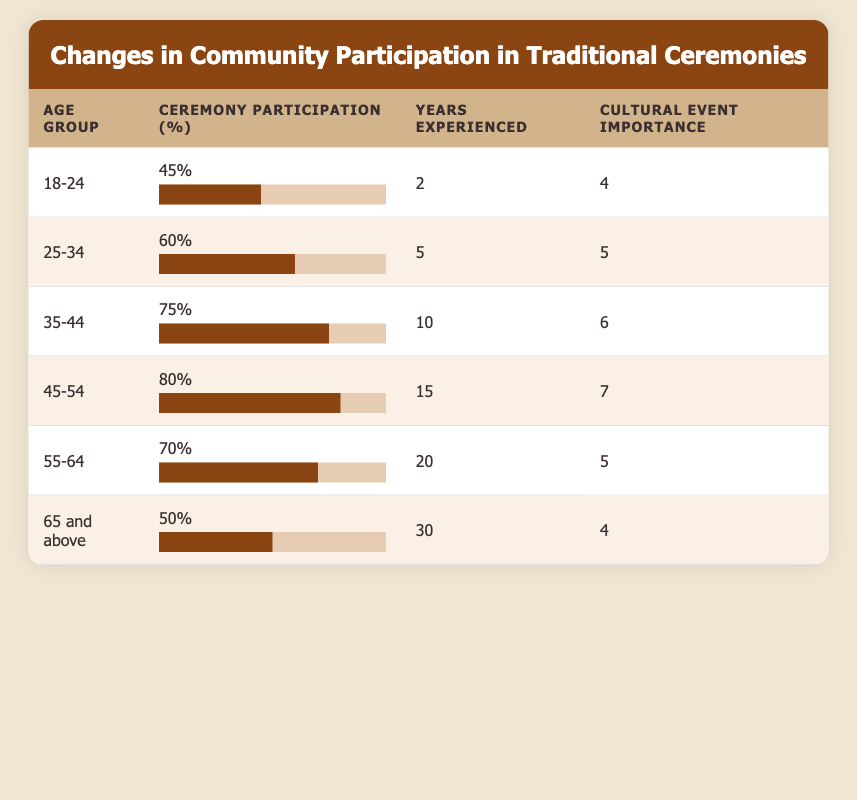What is the ceremony participation percentage for the age group 45-54? The table shows that the ceremony participation percentage for the age group 45-54 is listed directly in the corresponding row, which states 80%.
Answer: 80% Which age group has the highest years of experience in traditional ceremonies? By looking at the "Years Experienced" column, the age group 65 and above has the highest value of 30 years.
Answer: 65 and above What age group has a cultural event importance rating of 5? In the "Cultural Event Importance" column, the age groups 25-34 and 55-64 both have a rating of 5, as they are listed directly in the corresponding rows.
Answer: 25-34 and 55-64 What is the average ceremony participation percentage of all age groups? To find the average, we first sum up all the participation percentages: (45 + 60 + 75 + 80 + 70 + 50) = 380. There are 6 age groups, so we divide 380 by 6 which gives us approximately 63.33.
Answer: 63.33 Is it true that the age group 35-44 has a higher ceremony participation percentage than the age group 65 and above? By comparing the values, the age group 35-44 has a participation of 75%, whereas the age group 65 and above has 50%. Therefore, the statement is true.
Answer: Yes Which age group shows a decrease in ceremony participation compared to the previous group? Looking at the "Ceremony Participation" percentages sequentially, the participation decreased from 80% in the age group 45-54 to 70% in the age group 55-64.
Answer: 55-64 What is the total cultural event importance rating for all age groups? Summing the "Cultural Event Importance" ratings gives us: (4 + 5 + 6 + 7 + 5 + 4) = 31.
Answer: 31 Is the ceremony participation percentage for the 55-64 age group greater than the average participation percentage calculated earlier? The average participation percentage is approximately 63.33% and the 55-64 age group has a participation of 70%, which means this statement is true.
Answer: Yes 